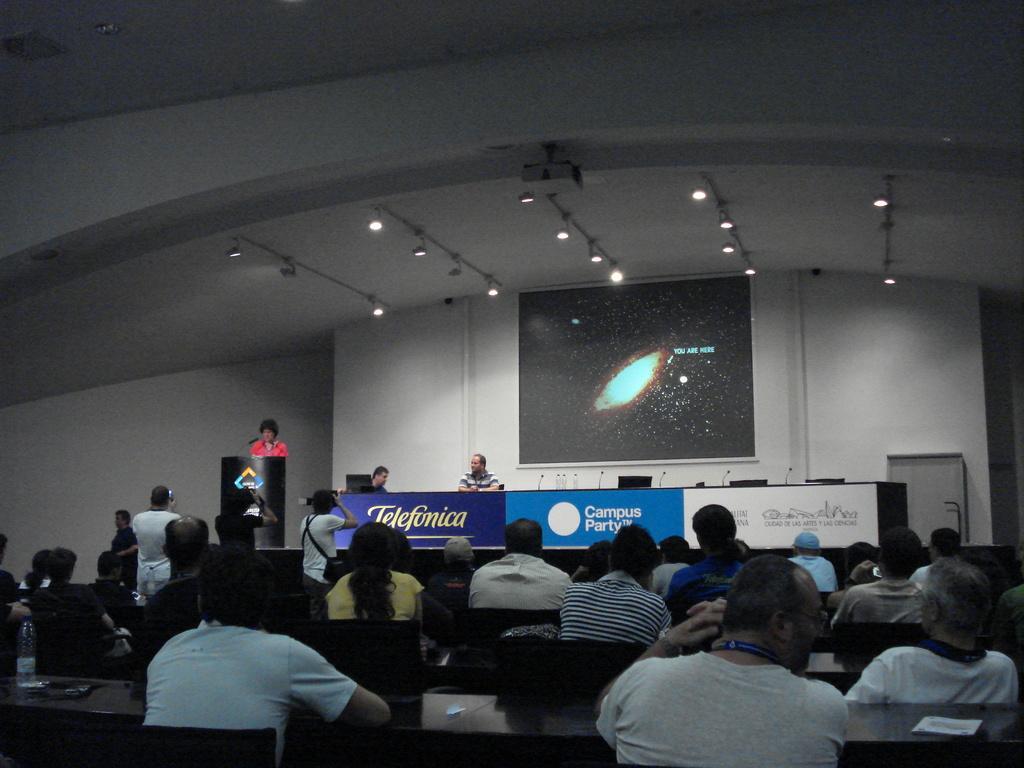Please provide a concise description of this image. In this image we can see a group of people sitting on chairs. In the center of the image we can see three persons holding cameras in their hands. Two persons are sitting on stage, a sign board with some text on it. On the left side, we can see a person standing in front of a podium with some microphones on it. In the background, we can see a door, screen and some lights. 